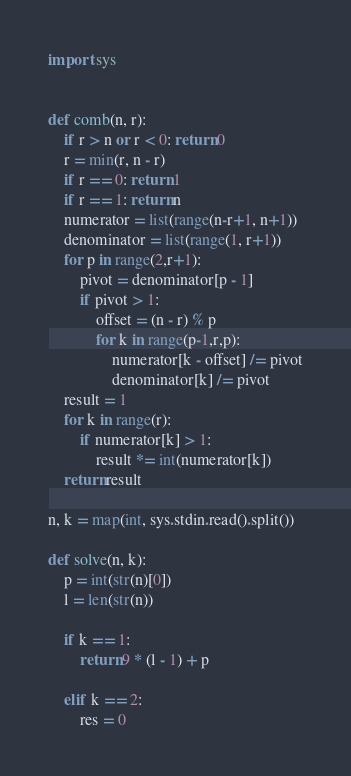<code> <loc_0><loc_0><loc_500><loc_500><_Python_>import sys


def comb(n, r):
    if r > n or r < 0: return 0
    r = min(r, n - r)
    if r == 0: return 1
    if r == 1: return n
    numerator = list(range(n-r+1, n+1))
    denominator = list(range(1, r+1))
    for p in range(2,r+1):
        pivot = denominator[p - 1]
        if pivot > 1:
            offset = (n - r) % p
            for k in range(p-1,r,p):
                numerator[k - offset] /= pivot
                denominator[k] /= pivot
    result = 1
    for k in range(r):
        if numerator[k] > 1:
            result *= int(numerator[k])
    return result

n, k = map(int, sys.stdin.read().split())

def solve(n, k):
    p = int(str(n)[0])
    l = len(str(n))

    if k == 1:
        return 9 * (l - 1) + p

    elif k == 2:
        res = 0</code> 